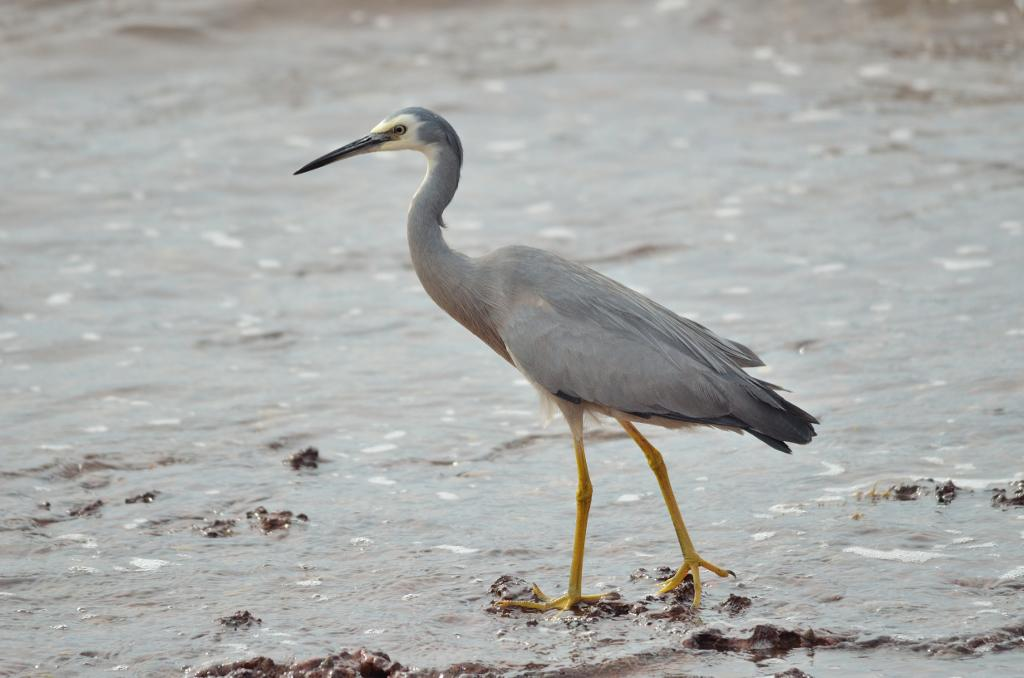What is located in the front of the image? There is a bird in the front of the image. What type of terrain is visible in the front of the image? There is mud in the front of the image. What is the condition of the background in the image? The background of the image is blurry. Can you see a footprint in the mud in the image? There is no mention of footprints in the mud in the image. What type of jelly is visible on the bird in the image? There is no jelly present on the bird in the image. 